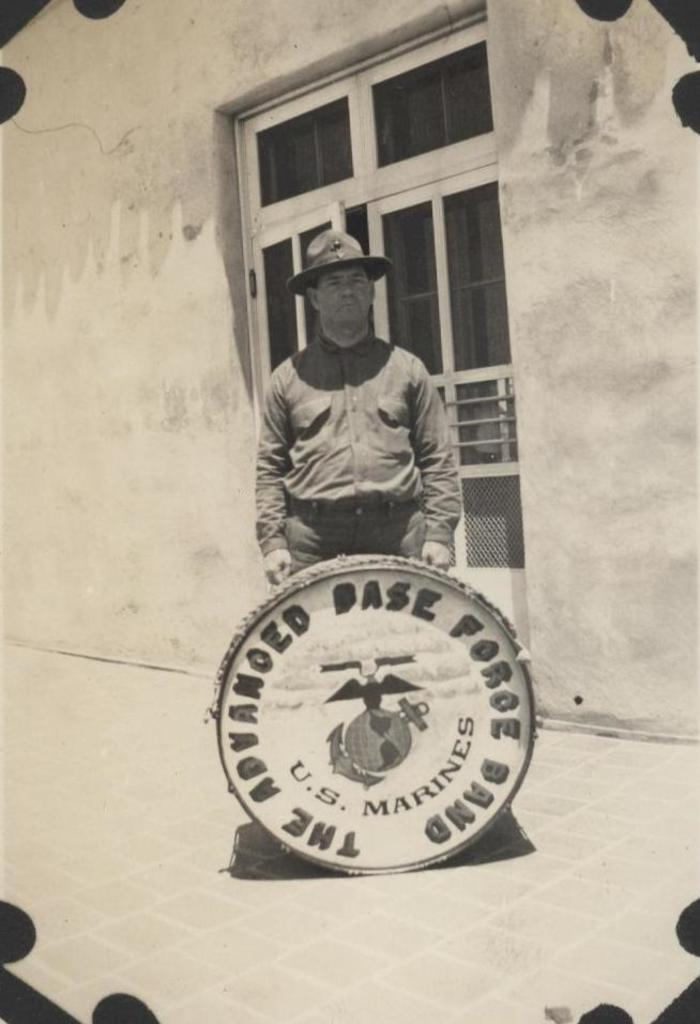Who or what is present in the image? There is a person in the image. What is located on the ground in front of the person? There is an object on the ground in front of the person. What can be seen in the background of the image? There is a wall and a window in the background of the image. How does the person measure the argument using their toe in the image? There is no mention of measuring an argument or using a toe in the image; the image only shows a person with an object on the ground and a wall and window in the background. 